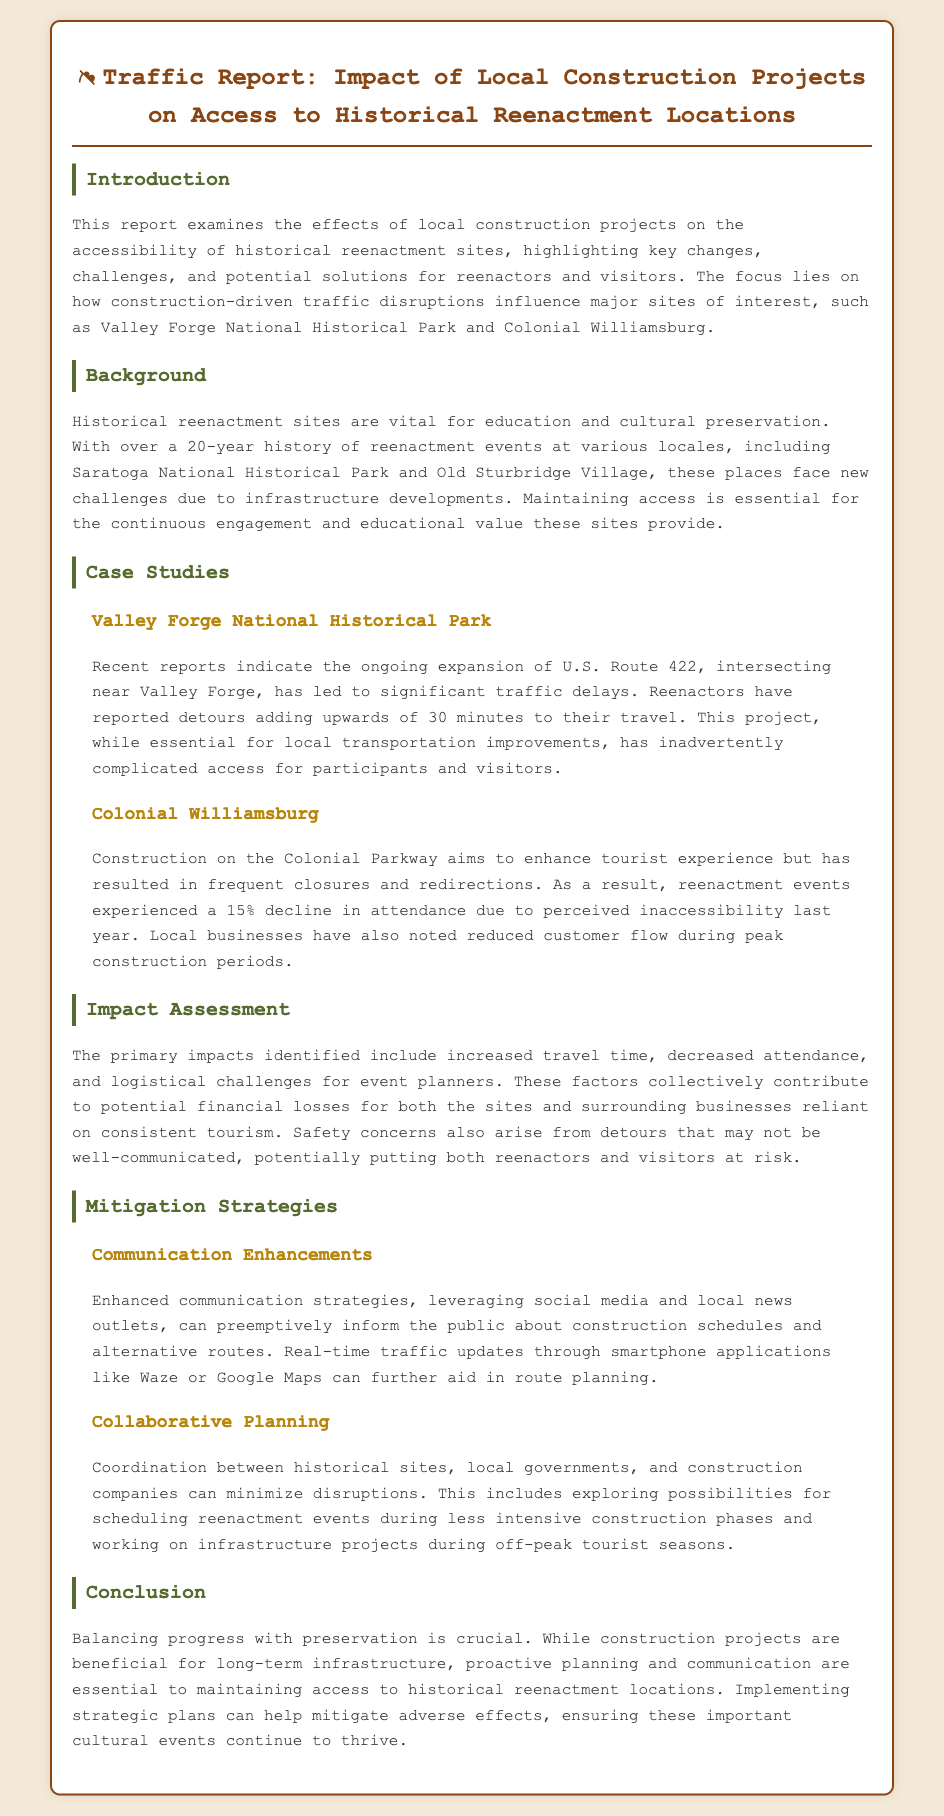What is the main focus of this report? The report examines the effects of local construction projects on the accessibility of historical reenactment sites.
Answer: accessibility of historical reenactment sites Which two historical sites are highlighted in the case studies? The title section mentioned the key case studies focusing on Valley Forge National Historical Park and Colonial Williamsburg.
Answer: Valley Forge National Historical Park and Colonial Williamsburg What has been the reported increase in travel time due to U.S. Route 422 expansion? Reenactors reported detours adding upwards of 30 minutes to their travel.
Answer: 30 minutes By what percentage did attendance decline in Colonial Williamsburg due to construction? The document states a 15% decline in attendance due to perceived inaccessibility.
Answer: 15% What type of strategies are recommended to improve communication? The report suggests enhanced communication strategies leveraging social media and local news outlets.
Answer: social media and local news outlets What can local governments and historical sites do to minimize disruptions? They can coordinate planning to minimize disruptions during intensive construction phases.
Answer: coordinate planning How are construction impacts described in the document? The impacts include increased travel time, decreased attendance, and logistical challenges for event planners.
Answer: increased travel time, decreased attendance, logistical challenges What is emphasized as crucial in the conclusion of the report? The conclusion emphasizes balancing progress with preservation as crucial.
Answer: balancing progress with preservation 